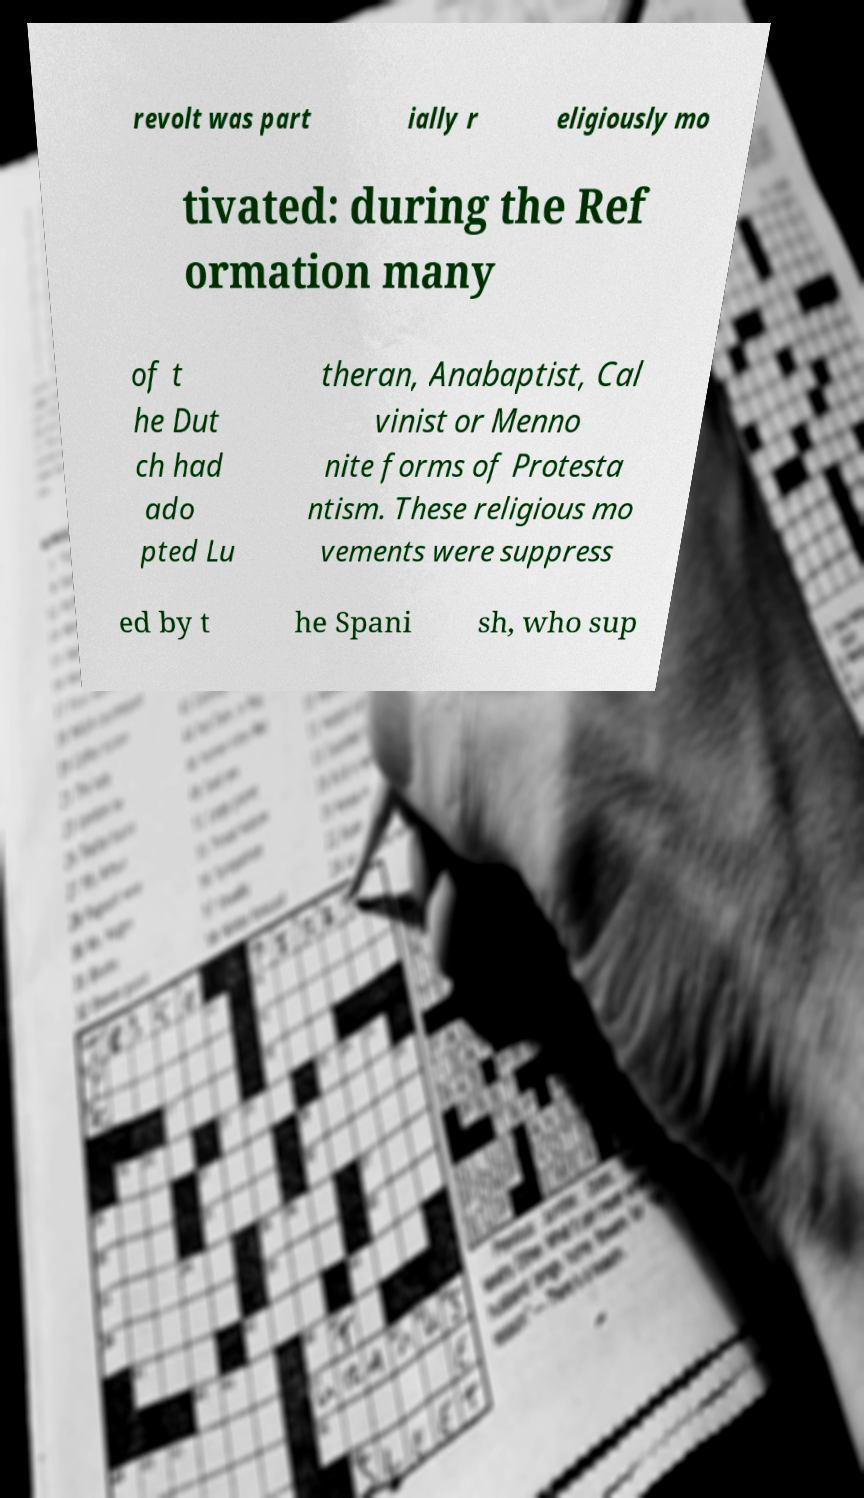There's text embedded in this image that I need extracted. Can you transcribe it verbatim? revolt was part ially r eligiously mo tivated: during the Ref ormation many of t he Dut ch had ado pted Lu theran, Anabaptist, Cal vinist or Menno nite forms of Protesta ntism. These religious mo vements were suppress ed by t he Spani sh, who sup 